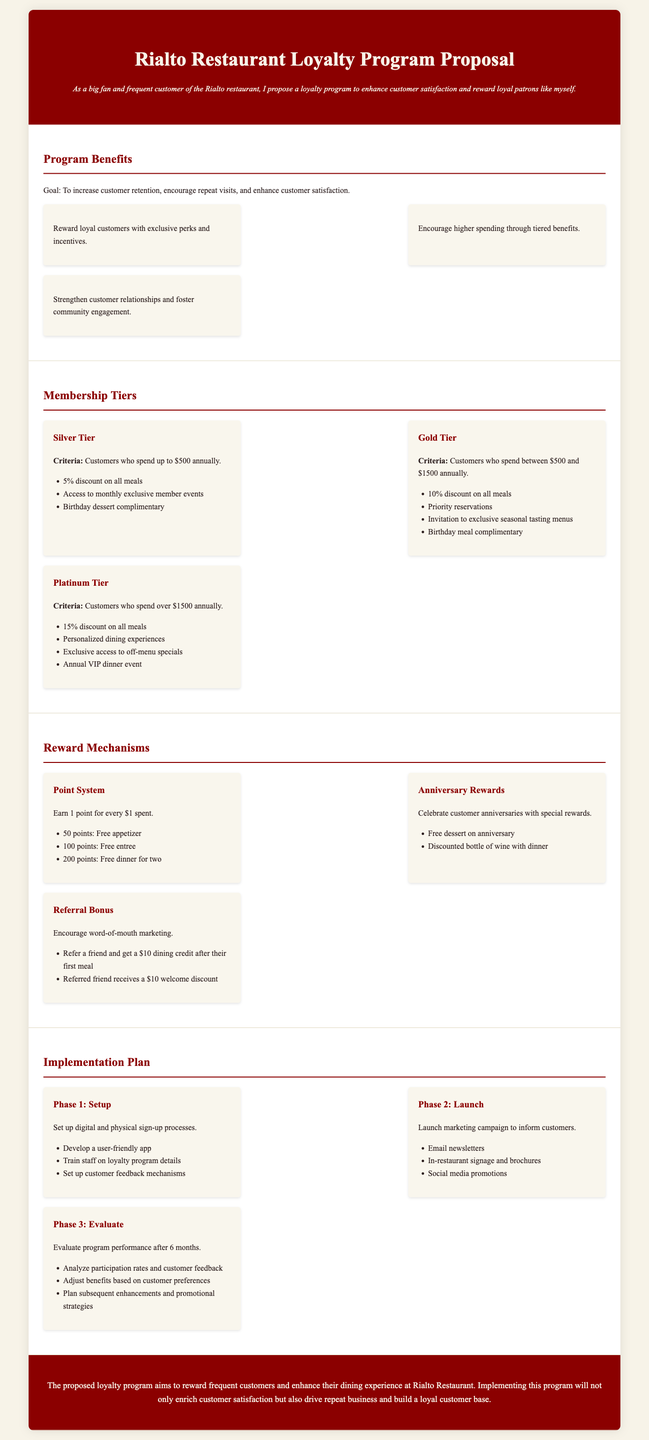what is the goal of the program? The goal of the program is to increase customer retention, encourage repeat visits, and enhance customer satisfaction.
Answer: increase customer retention, encourage repeat visits, and enhance customer satisfaction who spends up to $500 annually? This refers to customers in the Silver Tier membership category.
Answer: Silver Tier what is the discount for Gold Tier members? Gold Tier members receive a 10% discount on all meals.
Answer: 10% how many points do you earn for every dollar spent? The document states that customers earn 1 point for every dollar spent.
Answer: 1 point what reward do you receive on your anniversary? Customers receive a free dessert on their anniversary.
Answer: free dessert what are the three phases in the implementation plan? The phases are Setup, Launch, and Evaluate.
Answer: Setup, Launch, Evaluate how many points are needed for a free entree? Customers need 100 points for a free entree.
Answer: 100 points what benefit do Platinum Tier members receive annually? Platinum Tier members receive an annual VIP dinner event.
Answer: annual VIP dinner event what type of marketing campaign will be launched? A marketing campaign will be launched to inform customers.
Answer: marketing campaign 